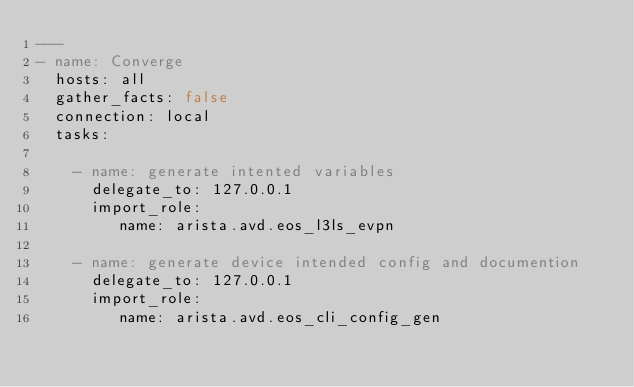Convert code to text. <code><loc_0><loc_0><loc_500><loc_500><_YAML_>---
- name: Converge
  hosts: all
  gather_facts: false
  connection: local
  tasks:

    - name: generate intented variables
      delegate_to: 127.0.0.1
      import_role:
         name: arista.avd.eos_l3ls_evpn

    - name: generate device intended config and documention
      delegate_to: 127.0.0.1
      import_role:
         name: arista.avd.eos_cli_config_gen
</code> 